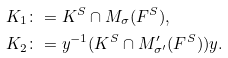<formula> <loc_0><loc_0><loc_500><loc_500>K _ { 1 } & \colon = K ^ { S } \cap M _ { \sigma } ( F ^ { S } ) , \\ K _ { 2 } & \colon = y ^ { - 1 } ( K ^ { S } \cap M ^ { \prime } _ { \sigma ^ { \prime } } ( F ^ { S } ) ) y .</formula> 